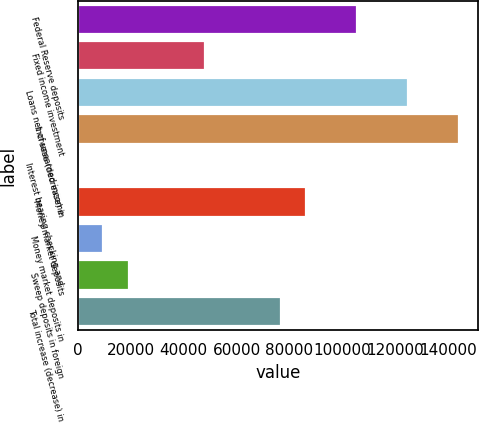<chart> <loc_0><loc_0><loc_500><loc_500><bar_chart><fcel>Federal Reserve deposits<fcel>Fixed income investment<fcel>Loans net of unearned income<fcel>Increase (decrease) in<fcel>Interest bearing checking and<fcel>Money market deposits<fcel>Money market deposits in<fcel>Sweep deposits in foreign<fcel>Total increase (decrease) in<nl><fcel>105546<fcel>47976.5<fcel>124736<fcel>143926<fcel>2<fcel>86356.1<fcel>9596.9<fcel>19191.8<fcel>76761.2<nl></chart> 